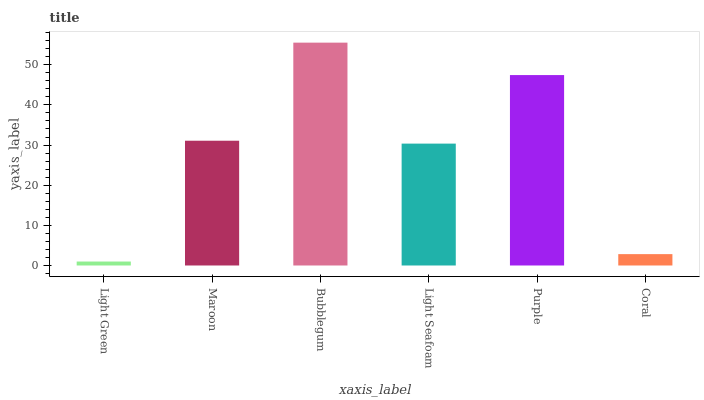Is Maroon the minimum?
Answer yes or no. No. Is Maroon the maximum?
Answer yes or no. No. Is Maroon greater than Light Green?
Answer yes or no. Yes. Is Light Green less than Maroon?
Answer yes or no. Yes. Is Light Green greater than Maroon?
Answer yes or no. No. Is Maroon less than Light Green?
Answer yes or no. No. Is Maroon the high median?
Answer yes or no. Yes. Is Light Seafoam the low median?
Answer yes or no. Yes. Is Coral the high median?
Answer yes or no. No. Is Maroon the low median?
Answer yes or no. No. 